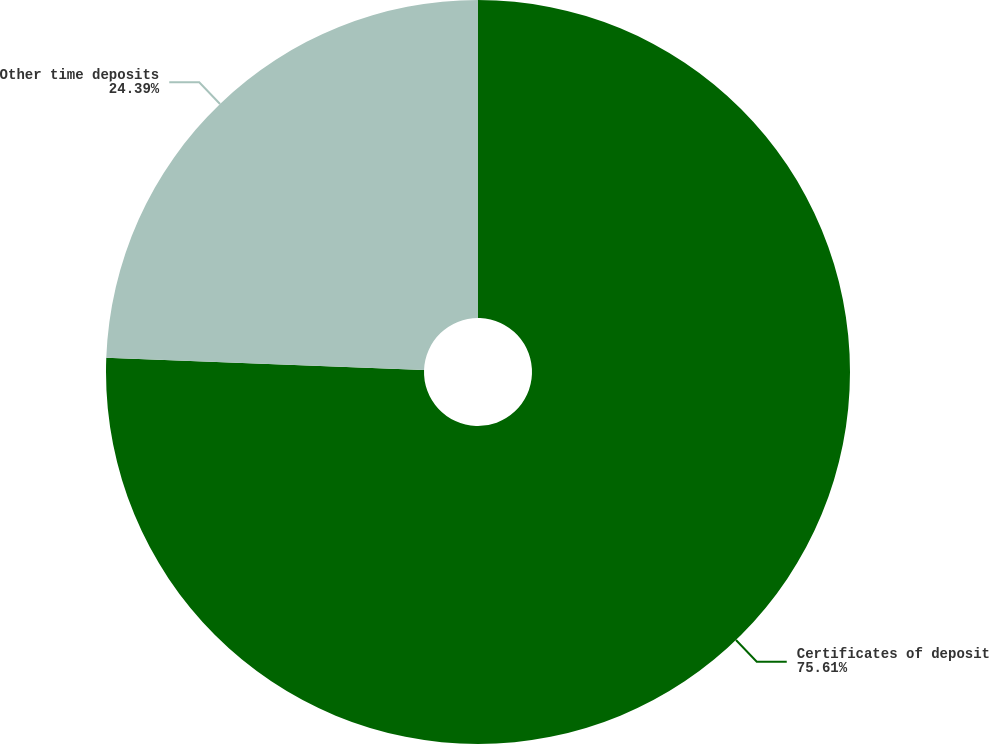Convert chart to OTSL. <chart><loc_0><loc_0><loc_500><loc_500><pie_chart><fcel>Certificates of deposit<fcel>Other time deposits<nl><fcel>75.61%<fcel>24.39%<nl></chart> 